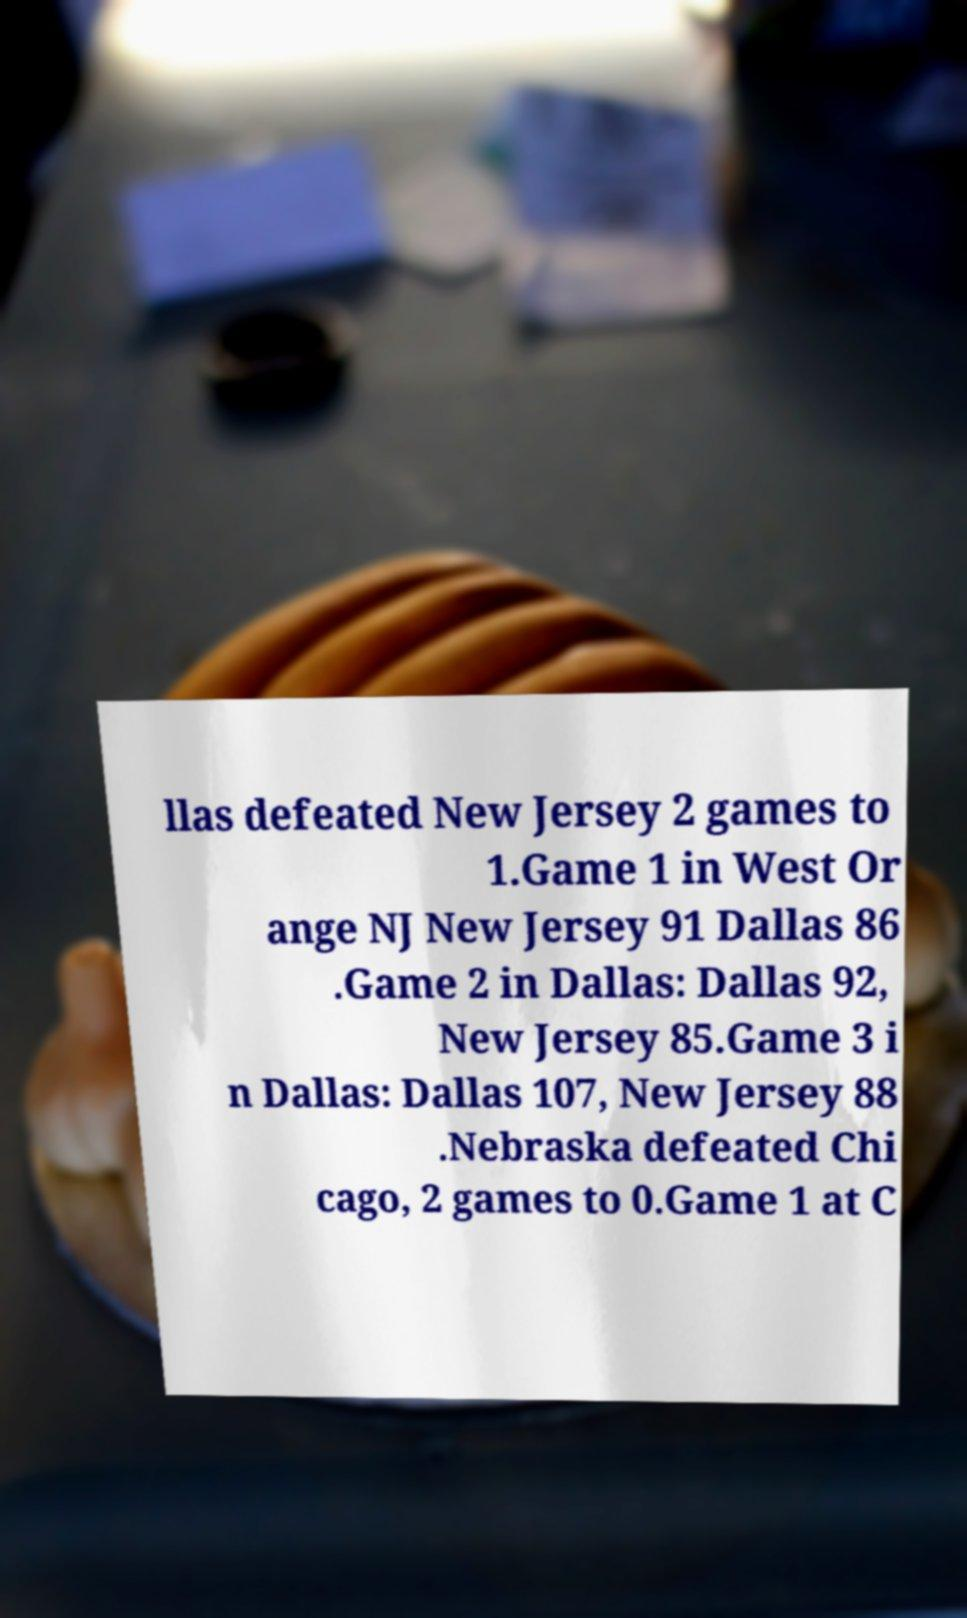Could you extract and type out the text from this image? llas defeated New Jersey 2 games to 1.Game 1 in West Or ange NJ New Jersey 91 Dallas 86 .Game 2 in Dallas: Dallas 92, New Jersey 85.Game 3 i n Dallas: Dallas 107, New Jersey 88 .Nebraska defeated Chi cago, 2 games to 0.Game 1 at C 